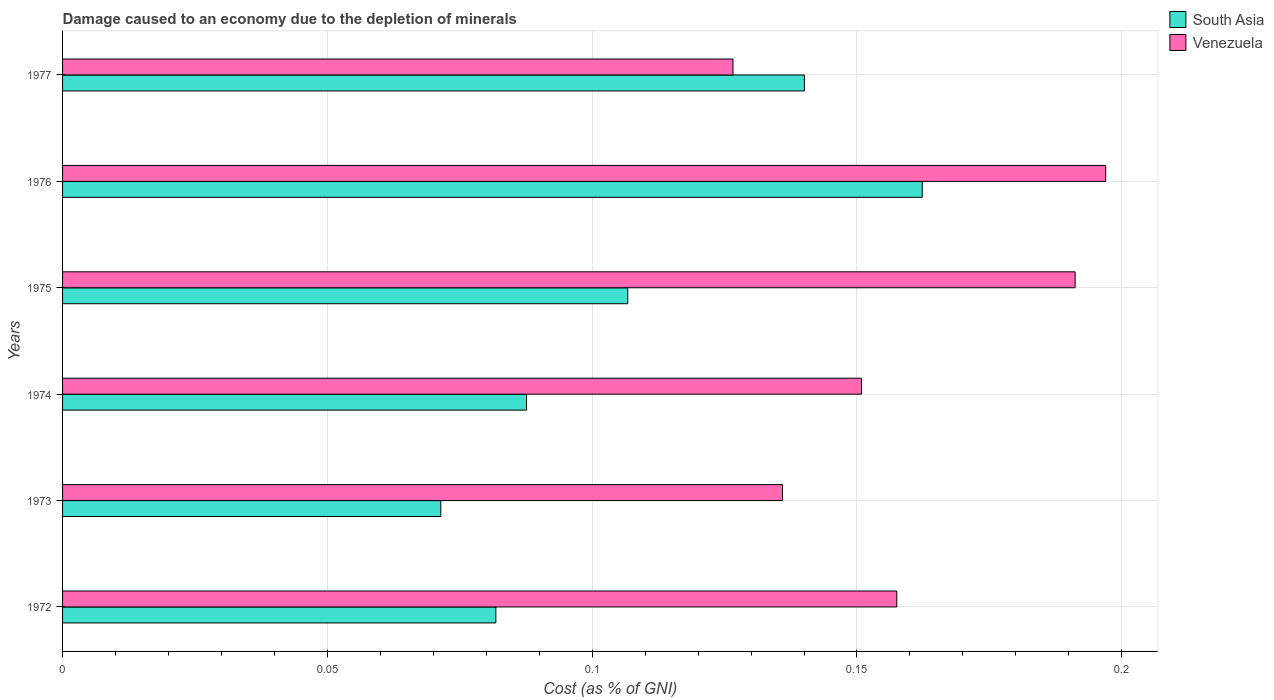How many groups of bars are there?
Provide a short and direct response. 6. Are the number of bars per tick equal to the number of legend labels?
Make the answer very short. Yes. Are the number of bars on each tick of the Y-axis equal?
Give a very brief answer. Yes. How many bars are there on the 1st tick from the top?
Keep it short and to the point. 2. In how many cases, is the number of bars for a given year not equal to the number of legend labels?
Your answer should be very brief. 0. What is the cost of damage caused due to the depletion of minerals in Venezuela in 1972?
Your answer should be very brief. 0.16. Across all years, what is the maximum cost of damage caused due to the depletion of minerals in Venezuela?
Provide a short and direct response. 0.2. Across all years, what is the minimum cost of damage caused due to the depletion of minerals in Venezuela?
Your answer should be very brief. 0.13. In which year was the cost of damage caused due to the depletion of minerals in Venezuela maximum?
Offer a very short reply. 1976. What is the total cost of damage caused due to the depletion of minerals in Venezuela in the graph?
Provide a succinct answer. 0.96. What is the difference between the cost of damage caused due to the depletion of minerals in South Asia in 1975 and that in 1976?
Offer a terse response. -0.06. What is the difference between the cost of damage caused due to the depletion of minerals in South Asia in 1975 and the cost of damage caused due to the depletion of minerals in Venezuela in 1974?
Give a very brief answer. -0.04. What is the average cost of damage caused due to the depletion of minerals in South Asia per year?
Give a very brief answer. 0.11. In the year 1972, what is the difference between the cost of damage caused due to the depletion of minerals in Venezuela and cost of damage caused due to the depletion of minerals in South Asia?
Give a very brief answer. 0.08. In how many years, is the cost of damage caused due to the depletion of minerals in South Asia greater than 0.08 %?
Provide a short and direct response. 5. What is the ratio of the cost of damage caused due to the depletion of minerals in Venezuela in 1975 to that in 1976?
Your answer should be very brief. 0.97. Is the cost of damage caused due to the depletion of minerals in South Asia in 1973 less than that in 1975?
Your answer should be compact. Yes. What is the difference between the highest and the second highest cost of damage caused due to the depletion of minerals in Venezuela?
Offer a very short reply. 0.01. What is the difference between the highest and the lowest cost of damage caused due to the depletion of minerals in Venezuela?
Offer a very short reply. 0.07. In how many years, is the cost of damage caused due to the depletion of minerals in Venezuela greater than the average cost of damage caused due to the depletion of minerals in Venezuela taken over all years?
Offer a terse response. 2. What does the 1st bar from the top in 1973 represents?
Offer a terse response. Venezuela. Are all the bars in the graph horizontal?
Give a very brief answer. Yes. Are the values on the major ticks of X-axis written in scientific E-notation?
Offer a very short reply. No. Does the graph contain grids?
Ensure brevity in your answer.  Yes. Where does the legend appear in the graph?
Your response must be concise. Top right. How many legend labels are there?
Offer a very short reply. 2. What is the title of the graph?
Give a very brief answer. Damage caused to an economy due to the depletion of minerals. What is the label or title of the X-axis?
Your response must be concise. Cost (as % of GNI). What is the Cost (as % of GNI) of South Asia in 1972?
Offer a terse response. 0.08. What is the Cost (as % of GNI) of Venezuela in 1972?
Your response must be concise. 0.16. What is the Cost (as % of GNI) in South Asia in 1973?
Provide a short and direct response. 0.07. What is the Cost (as % of GNI) of Venezuela in 1973?
Offer a terse response. 0.14. What is the Cost (as % of GNI) in South Asia in 1974?
Your answer should be very brief. 0.09. What is the Cost (as % of GNI) in Venezuela in 1974?
Offer a terse response. 0.15. What is the Cost (as % of GNI) of South Asia in 1975?
Provide a succinct answer. 0.11. What is the Cost (as % of GNI) of Venezuela in 1975?
Provide a short and direct response. 0.19. What is the Cost (as % of GNI) of South Asia in 1976?
Your response must be concise. 0.16. What is the Cost (as % of GNI) of Venezuela in 1976?
Offer a terse response. 0.2. What is the Cost (as % of GNI) in South Asia in 1977?
Ensure brevity in your answer.  0.14. What is the Cost (as % of GNI) of Venezuela in 1977?
Ensure brevity in your answer.  0.13. Across all years, what is the maximum Cost (as % of GNI) in South Asia?
Provide a succinct answer. 0.16. Across all years, what is the maximum Cost (as % of GNI) in Venezuela?
Provide a succinct answer. 0.2. Across all years, what is the minimum Cost (as % of GNI) in South Asia?
Keep it short and to the point. 0.07. Across all years, what is the minimum Cost (as % of GNI) of Venezuela?
Make the answer very short. 0.13. What is the total Cost (as % of GNI) of South Asia in the graph?
Your response must be concise. 0.65. What is the total Cost (as % of GNI) of Venezuela in the graph?
Offer a very short reply. 0.96. What is the difference between the Cost (as % of GNI) of South Asia in 1972 and that in 1973?
Make the answer very short. 0.01. What is the difference between the Cost (as % of GNI) of Venezuela in 1972 and that in 1973?
Offer a very short reply. 0.02. What is the difference between the Cost (as % of GNI) of South Asia in 1972 and that in 1974?
Your answer should be very brief. -0.01. What is the difference between the Cost (as % of GNI) of Venezuela in 1972 and that in 1974?
Offer a terse response. 0.01. What is the difference between the Cost (as % of GNI) of South Asia in 1972 and that in 1975?
Your answer should be very brief. -0.02. What is the difference between the Cost (as % of GNI) in Venezuela in 1972 and that in 1975?
Provide a succinct answer. -0.03. What is the difference between the Cost (as % of GNI) in South Asia in 1972 and that in 1976?
Make the answer very short. -0.08. What is the difference between the Cost (as % of GNI) of Venezuela in 1972 and that in 1976?
Your answer should be very brief. -0.04. What is the difference between the Cost (as % of GNI) of South Asia in 1972 and that in 1977?
Offer a very short reply. -0.06. What is the difference between the Cost (as % of GNI) in Venezuela in 1972 and that in 1977?
Keep it short and to the point. 0.03. What is the difference between the Cost (as % of GNI) in South Asia in 1973 and that in 1974?
Keep it short and to the point. -0.02. What is the difference between the Cost (as % of GNI) in Venezuela in 1973 and that in 1974?
Your answer should be compact. -0.01. What is the difference between the Cost (as % of GNI) in South Asia in 1973 and that in 1975?
Keep it short and to the point. -0.04. What is the difference between the Cost (as % of GNI) in Venezuela in 1973 and that in 1975?
Your answer should be very brief. -0.06. What is the difference between the Cost (as % of GNI) of South Asia in 1973 and that in 1976?
Your answer should be very brief. -0.09. What is the difference between the Cost (as % of GNI) of Venezuela in 1973 and that in 1976?
Your answer should be compact. -0.06. What is the difference between the Cost (as % of GNI) in South Asia in 1973 and that in 1977?
Your answer should be compact. -0.07. What is the difference between the Cost (as % of GNI) of Venezuela in 1973 and that in 1977?
Your answer should be very brief. 0.01. What is the difference between the Cost (as % of GNI) in South Asia in 1974 and that in 1975?
Your answer should be very brief. -0.02. What is the difference between the Cost (as % of GNI) in Venezuela in 1974 and that in 1975?
Keep it short and to the point. -0.04. What is the difference between the Cost (as % of GNI) in South Asia in 1974 and that in 1976?
Your answer should be compact. -0.07. What is the difference between the Cost (as % of GNI) in Venezuela in 1974 and that in 1976?
Your answer should be compact. -0.05. What is the difference between the Cost (as % of GNI) in South Asia in 1974 and that in 1977?
Give a very brief answer. -0.05. What is the difference between the Cost (as % of GNI) of Venezuela in 1974 and that in 1977?
Your answer should be compact. 0.02. What is the difference between the Cost (as % of GNI) in South Asia in 1975 and that in 1976?
Keep it short and to the point. -0.06. What is the difference between the Cost (as % of GNI) of Venezuela in 1975 and that in 1976?
Provide a succinct answer. -0.01. What is the difference between the Cost (as % of GNI) of South Asia in 1975 and that in 1977?
Offer a terse response. -0.03. What is the difference between the Cost (as % of GNI) in Venezuela in 1975 and that in 1977?
Give a very brief answer. 0.06. What is the difference between the Cost (as % of GNI) of South Asia in 1976 and that in 1977?
Provide a short and direct response. 0.02. What is the difference between the Cost (as % of GNI) in Venezuela in 1976 and that in 1977?
Your answer should be compact. 0.07. What is the difference between the Cost (as % of GNI) in South Asia in 1972 and the Cost (as % of GNI) in Venezuela in 1973?
Provide a short and direct response. -0.05. What is the difference between the Cost (as % of GNI) in South Asia in 1972 and the Cost (as % of GNI) in Venezuela in 1974?
Give a very brief answer. -0.07. What is the difference between the Cost (as % of GNI) in South Asia in 1972 and the Cost (as % of GNI) in Venezuela in 1975?
Ensure brevity in your answer.  -0.11. What is the difference between the Cost (as % of GNI) in South Asia in 1972 and the Cost (as % of GNI) in Venezuela in 1976?
Make the answer very short. -0.12. What is the difference between the Cost (as % of GNI) in South Asia in 1972 and the Cost (as % of GNI) in Venezuela in 1977?
Provide a succinct answer. -0.04. What is the difference between the Cost (as % of GNI) in South Asia in 1973 and the Cost (as % of GNI) in Venezuela in 1974?
Ensure brevity in your answer.  -0.08. What is the difference between the Cost (as % of GNI) in South Asia in 1973 and the Cost (as % of GNI) in Venezuela in 1975?
Make the answer very short. -0.12. What is the difference between the Cost (as % of GNI) in South Asia in 1973 and the Cost (as % of GNI) in Venezuela in 1976?
Offer a terse response. -0.13. What is the difference between the Cost (as % of GNI) of South Asia in 1973 and the Cost (as % of GNI) of Venezuela in 1977?
Your response must be concise. -0.06. What is the difference between the Cost (as % of GNI) of South Asia in 1974 and the Cost (as % of GNI) of Venezuela in 1975?
Make the answer very short. -0.1. What is the difference between the Cost (as % of GNI) of South Asia in 1974 and the Cost (as % of GNI) of Venezuela in 1976?
Give a very brief answer. -0.11. What is the difference between the Cost (as % of GNI) of South Asia in 1974 and the Cost (as % of GNI) of Venezuela in 1977?
Provide a short and direct response. -0.04. What is the difference between the Cost (as % of GNI) in South Asia in 1975 and the Cost (as % of GNI) in Venezuela in 1976?
Keep it short and to the point. -0.09. What is the difference between the Cost (as % of GNI) of South Asia in 1975 and the Cost (as % of GNI) of Venezuela in 1977?
Offer a terse response. -0.02. What is the difference between the Cost (as % of GNI) in South Asia in 1976 and the Cost (as % of GNI) in Venezuela in 1977?
Your answer should be compact. 0.04. What is the average Cost (as % of GNI) in South Asia per year?
Keep it short and to the point. 0.11. What is the average Cost (as % of GNI) in Venezuela per year?
Give a very brief answer. 0.16. In the year 1972, what is the difference between the Cost (as % of GNI) in South Asia and Cost (as % of GNI) in Venezuela?
Ensure brevity in your answer.  -0.08. In the year 1973, what is the difference between the Cost (as % of GNI) in South Asia and Cost (as % of GNI) in Venezuela?
Your answer should be compact. -0.06. In the year 1974, what is the difference between the Cost (as % of GNI) of South Asia and Cost (as % of GNI) of Venezuela?
Your answer should be compact. -0.06. In the year 1975, what is the difference between the Cost (as % of GNI) in South Asia and Cost (as % of GNI) in Venezuela?
Your answer should be very brief. -0.08. In the year 1976, what is the difference between the Cost (as % of GNI) of South Asia and Cost (as % of GNI) of Venezuela?
Make the answer very short. -0.03. In the year 1977, what is the difference between the Cost (as % of GNI) in South Asia and Cost (as % of GNI) in Venezuela?
Make the answer very short. 0.01. What is the ratio of the Cost (as % of GNI) in South Asia in 1972 to that in 1973?
Keep it short and to the point. 1.15. What is the ratio of the Cost (as % of GNI) in Venezuela in 1972 to that in 1973?
Offer a very short reply. 1.16. What is the ratio of the Cost (as % of GNI) in South Asia in 1972 to that in 1974?
Your answer should be compact. 0.93. What is the ratio of the Cost (as % of GNI) in Venezuela in 1972 to that in 1974?
Ensure brevity in your answer.  1.04. What is the ratio of the Cost (as % of GNI) in South Asia in 1972 to that in 1975?
Keep it short and to the point. 0.77. What is the ratio of the Cost (as % of GNI) in Venezuela in 1972 to that in 1975?
Make the answer very short. 0.82. What is the ratio of the Cost (as % of GNI) of South Asia in 1972 to that in 1976?
Provide a succinct answer. 0.5. What is the ratio of the Cost (as % of GNI) of Venezuela in 1972 to that in 1976?
Your answer should be compact. 0.8. What is the ratio of the Cost (as % of GNI) of South Asia in 1972 to that in 1977?
Keep it short and to the point. 0.58. What is the ratio of the Cost (as % of GNI) of Venezuela in 1972 to that in 1977?
Your answer should be compact. 1.24. What is the ratio of the Cost (as % of GNI) in South Asia in 1973 to that in 1974?
Your answer should be compact. 0.82. What is the ratio of the Cost (as % of GNI) of Venezuela in 1973 to that in 1974?
Keep it short and to the point. 0.9. What is the ratio of the Cost (as % of GNI) of South Asia in 1973 to that in 1975?
Your response must be concise. 0.67. What is the ratio of the Cost (as % of GNI) of Venezuela in 1973 to that in 1975?
Your answer should be compact. 0.71. What is the ratio of the Cost (as % of GNI) in South Asia in 1973 to that in 1976?
Your response must be concise. 0.44. What is the ratio of the Cost (as % of GNI) of Venezuela in 1973 to that in 1976?
Offer a terse response. 0.69. What is the ratio of the Cost (as % of GNI) of South Asia in 1973 to that in 1977?
Your answer should be compact. 0.51. What is the ratio of the Cost (as % of GNI) of Venezuela in 1973 to that in 1977?
Make the answer very short. 1.07. What is the ratio of the Cost (as % of GNI) of South Asia in 1974 to that in 1975?
Offer a terse response. 0.82. What is the ratio of the Cost (as % of GNI) in Venezuela in 1974 to that in 1975?
Offer a very short reply. 0.79. What is the ratio of the Cost (as % of GNI) in South Asia in 1974 to that in 1976?
Offer a very short reply. 0.54. What is the ratio of the Cost (as % of GNI) of Venezuela in 1974 to that in 1976?
Ensure brevity in your answer.  0.77. What is the ratio of the Cost (as % of GNI) of South Asia in 1974 to that in 1977?
Make the answer very short. 0.63. What is the ratio of the Cost (as % of GNI) of Venezuela in 1974 to that in 1977?
Make the answer very short. 1.19. What is the ratio of the Cost (as % of GNI) in South Asia in 1975 to that in 1976?
Give a very brief answer. 0.66. What is the ratio of the Cost (as % of GNI) in Venezuela in 1975 to that in 1976?
Your response must be concise. 0.97. What is the ratio of the Cost (as % of GNI) of South Asia in 1975 to that in 1977?
Offer a very short reply. 0.76. What is the ratio of the Cost (as % of GNI) in Venezuela in 1975 to that in 1977?
Offer a terse response. 1.51. What is the ratio of the Cost (as % of GNI) in South Asia in 1976 to that in 1977?
Offer a terse response. 1.16. What is the ratio of the Cost (as % of GNI) in Venezuela in 1976 to that in 1977?
Offer a very short reply. 1.56. What is the difference between the highest and the second highest Cost (as % of GNI) in South Asia?
Provide a succinct answer. 0.02. What is the difference between the highest and the second highest Cost (as % of GNI) in Venezuela?
Give a very brief answer. 0.01. What is the difference between the highest and the lowest Cost (as % of GNI) in South Asia?
Provide a succinct answer. 0.09. What is the difference between the highest and the lowest Cost (as % of GNI) of Venezuela?
Offer a very short reply. 0.07. 